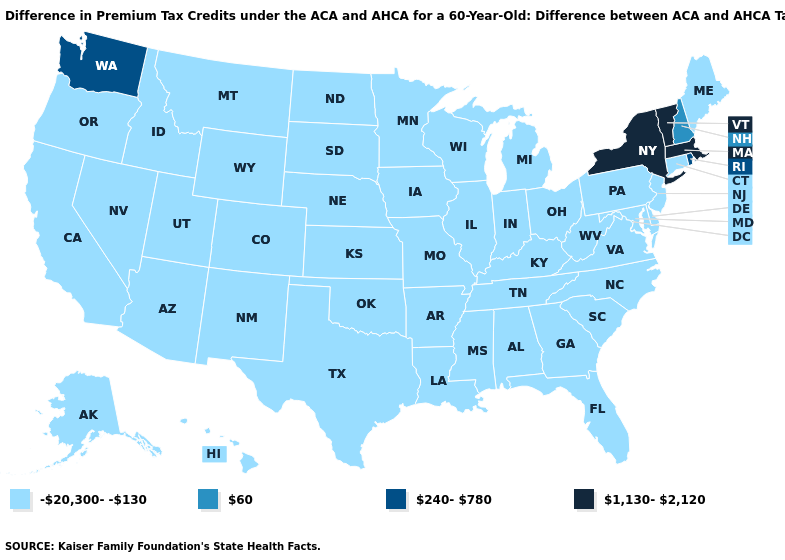What is the highest value in the USA?
Keep it brief. 1,130-2,120. Which states have the lowest value in the USA?
Write a very short answer. Alabama, Alaska, Arizona, Arkansas, California, Colorado, Connecticut, Delaware, Florida, Georgia, Hawaii, Idaho, Illinois, Indiana, Iowa, Kansas, Kentucky, Louisiana, Maine, Maryland, Michigan, Minnesota, Mississippi, Missouri, Montana, Nebraska, Nevada, New Jersey, New Mexico, North Carolina, North Dakota, Ohio, Oklahoma, Oregon, Pennsylvania, South Carolina, South Dakota, Tennessee, Texas, Utah, Virginia, West Virginia, Wisconsin, Wyoming. What is the value of Maine?
Quick response, please. -20,300--130. What is the value of South Dakota?
Concise answer only. -20,300--130. What is the value of South Carolina?
Give a very brief answer. -20,300--130. Does the first symbol in the legend represent the smallest category?
Concise answer only. Yes. Which states hav the highest value in the South?
Write a very short answer. Alabama, Arkansas, Delaware, Florida, Georgia, Kentucky, Louisiana, Maryland, Mississippi, North Carolina, Oklahoma, South Carolina, Tennessee, Texas, Virginia, West Virginia. What is the value of Utah?
Short answer required. -20,300--130. Name the states that have a value in the range 60?
Concise answer only. New Hampshire. What is the value of Washington?
Short answer required. 240-780. Is the legend a continuous bar?
Write a very short answer. No. Does Michigan have the highest value in the USA?
Write a very short answer. No. What is the highest value in the USA?
Give a very brief answer. 1,130-2,120. Among the states that border New Mexico , which have the lowest value?
Keep it brief. Arizona, Colorado, Oklahoma, Texas, Utah. What is the value of Alaska?
Be succinct. -20,300--130. 